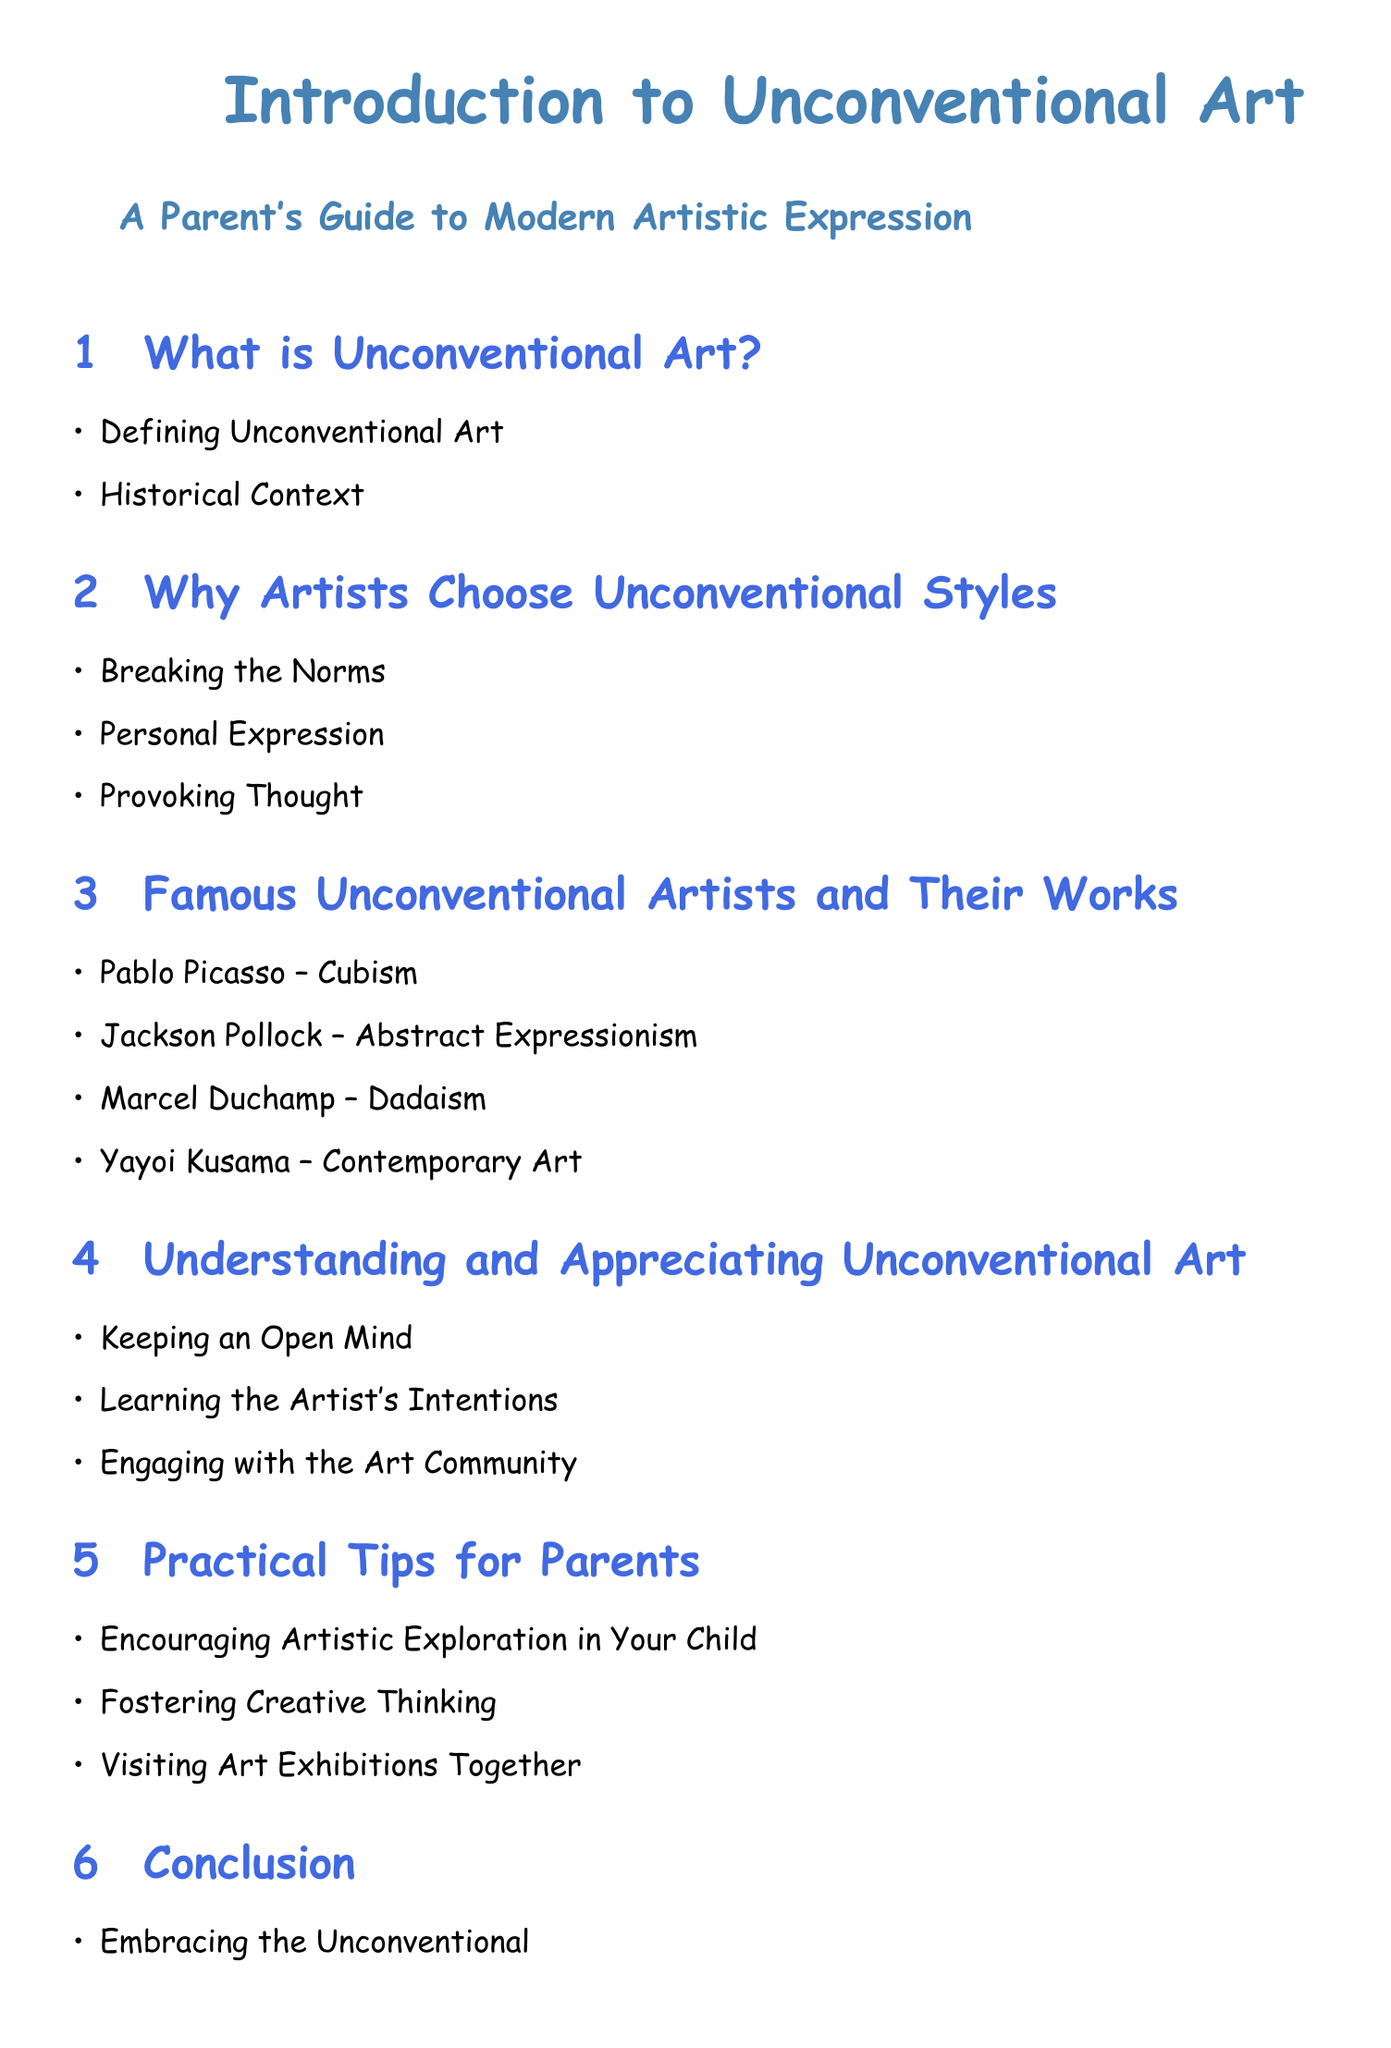What is Unconventional Art? The document begins with a section that defines Unconventional Art and provides a historical context for it.
Answer: What is Unconventional Art? Why do artists choose unconventional styles? This question relates to a section that discusses the reasons artists opt for unconventional artistic expressions, such as breaking norms and provoking thought.
Answer: Why Artists Choose Unconventional Styles Name a famous unconventional artist mentioned in the document. The document lists several famous unconventional artists, including Pablo Picasso, Jackson Pollock, Marcel Duchamp, and Yayoi Kusama.
Answer: Pablo Picasso What art movement is Jackson Pollock associated with? The document specifies that Jackson Pollock is associated with Abstract Expressionism.
Answer: Abstract Expressionism What should parents do to encourage artistic exploration? There's a section outlining practical tips for parents, specifically highlighting encouraging artistic exploration in their children.
Answer: Encouraging Artistic Exploration in Your Child How many sections are in the document? Counting the main headings in the table of contents will give the total number of sections, which include Introduction, Why Artists Choose Unconventional Styles, Famous Artists, etc.
Answer: 6 What is the concluding theme of the document? The document indicates that the conclusion emphasizes embracing unconventional art.
Answer: Embracing the Unconventional What color is used for the section titles? The document uses a specific color for the section titles, differentiating them visually from other text.
Answer: Section Color 